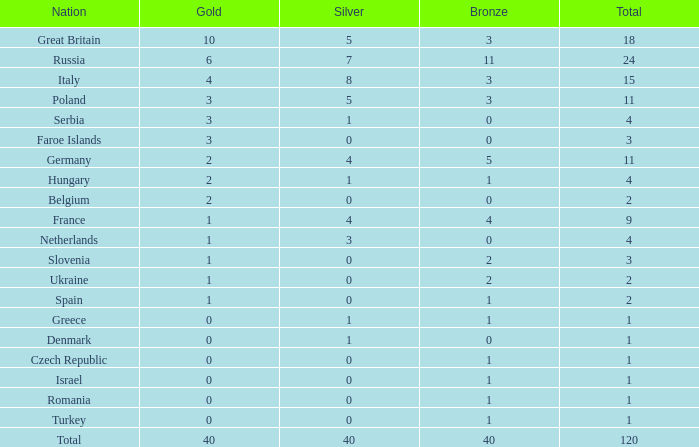Which country has a gold count exceeding 0, a total greater than 2, a silver count surpassing 1, and no bronze medals? Netherlands. 